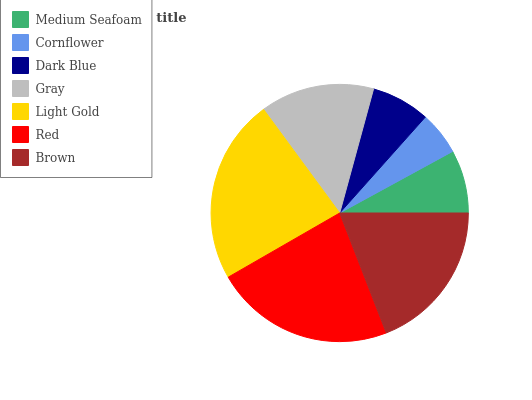Is Cornflower the minimum?
Answer yes or no. Yes. Is Light Gold the maximum?
Answer yes or no. Yes. Is Dark Blue the minimum?
Answer yes or no. No. Is Dark Blue the maximum?
Answer yes or no. No. Is Dark Blue greater than Cornflower?
Answer yes or no. Yes. Is Cornflower less than Dark Blue?
Answer yes or no. Yes. Is Cornflower greater than Dark Blue?
Answer yes or no. No. Is Dark Blue less than Cornflower?
Answer yes or no. No. Is Gray the high median?
Answer yes or no. Yes. Is Gray the low median?
Answer yes or no. Yes. Is Cornflower the high median?
Answer yes or no. No. Is Light Gold the low median?
Answer yes or no. No. 